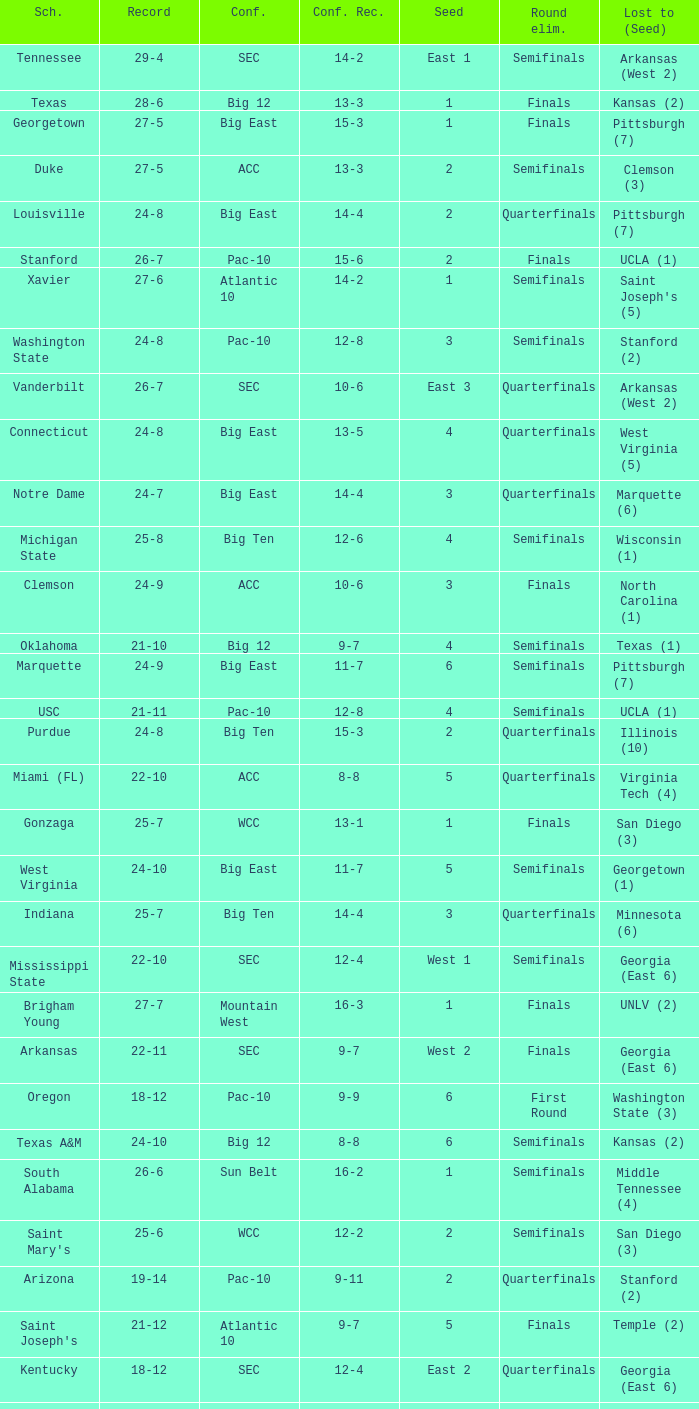Name the school where conference record is 12-6 Michigan State. 